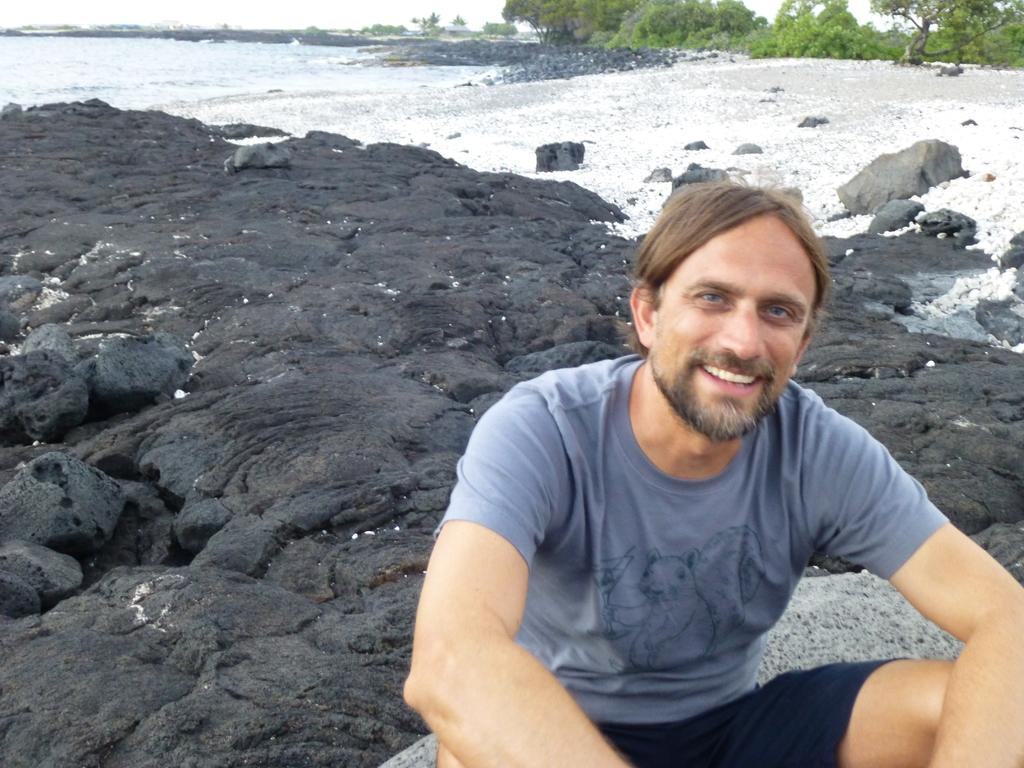What is the man in the image doing? The man is sitting on a rock in the image. What is on the ground behind the man? There are rocks on the ground behind the man. What can be seen in the distance in the image? There are trees and water visible in the background of the image. What is visible at the top of the image? The sky is visible at the top of the image. What type of question can be seen floating in the water in the image? There is no question visible in the image, let alone one floating in the water. 